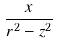<formula> <loc_0><loc_0><loc_500><loc_500>\frac { x } { r ^ { 2 } - z ^ { 2 } }</formula> 